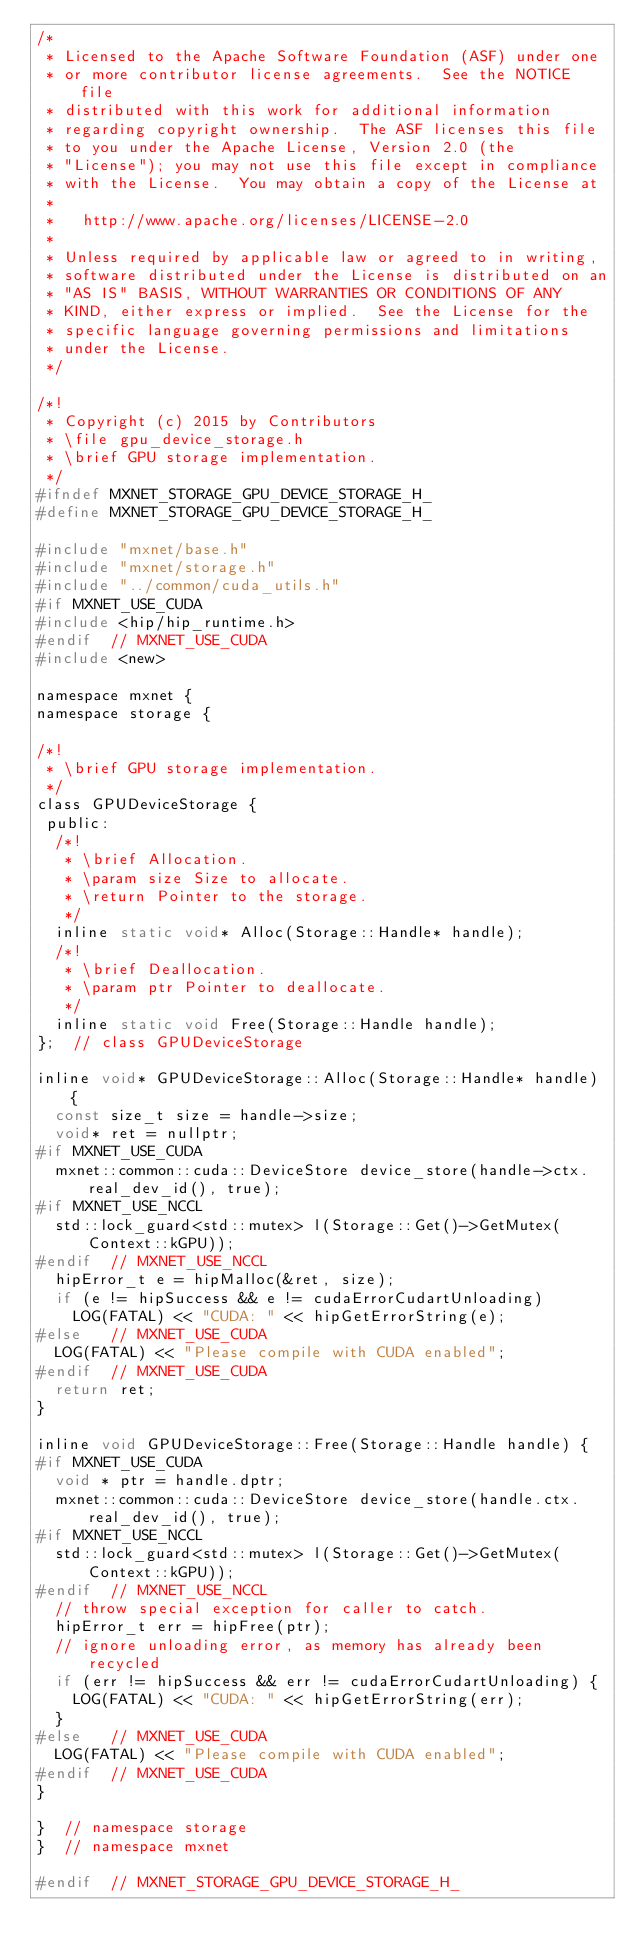Convert code to text. <code><loc_0><loc_0><loc_500><loc_500><_C_>/*
 * Licensed to the Apache Software Foundation (ASF) under one
 * or more contributor license agreements.  See the NOTICE file
 * distributed with this work for additional information
 * regarding copyright ownership.  The ASF licenses this file
 * to you under the Apache License, Version 2.0 (the
 * "License"); you may not use this file except in compliance
 * with the License.  You may obtain a copy of the License at
 *
 *   http://www.apache.org/licenses/LICENSE-2.0
 *
 * Unless required by applicable law or agreed to in writing,
 * software distributed under the License is distributed on an
 * "AS IS" BASIS, WITHOUT WARRANTIES OR CONDITIONS OF ANY
 * KIND, either express or implied.  See the License for the
 * specific language governing permissions and limitations
 * under the License.
 */

/*!
 * Copyright (c) 2015 by Contributors
 * \file gpu_device_storage.h
 * \brief GPU storage implementation.
 */
#ifndef MXNET_STORAGE_GPU_DEVICE_STORAGE_H_
#define MXNET_STORAGE_GPU_DEVICE_STORAGE_H_

#include "mxnet/base.h"
#include "mxnet/storage.h"
#include "../common/cuda_utils.h"
#if MXNET_USE_CUDA
#include <hip/hip_runtime.h>
#endif  // MXNET_USE_CUDA
#include <new>

namespace mxnet {
namespace storage {

/*!
 * \brief GPU storage implementation.
 */
class GPUDeviceStorage {
 public:
  /*!
   * \brief Allocation.
   * \param size Size to allocate.
   * \return Pointer to the storage.
   */
  inline static void* Alloc(Storage::Handle* handle);
  /*!
   * \brief Deallocation.
   * \param ptr Pointer to deallocate.
   */
  inline static void Free(Storage::Handle handle);
};  // class GPUDeviceStorage

inline void* GPUDeviceStorage::Alloc(Storage::Handle* handle) {
  const size_t size = handle->size;
  void* ret = nullptr;
#if MXNET_USE_CUDA
  mxnet::common::cuda::DeviceStore device_store(handle->ctx.real_dev_id(), true);
#if MXNET_USE_NCCL
  std::lock_guard<std::mutex> l(Storage::Get()->GetMutex(Context::kGPU));
#endif  // MXNET_USE_NCCL
  hipError_t e = hipMalloc(&ret, size);
  if (e != hipSuccess && e != cudaErrorCudartUnloading)
    LOG(FATAL) << "CUDA: " << hipGetErrorString(e);
#else   // MXNET_USE_CUDA
  LOG(FATAL) << "Please compile with CUDA enabled";
#endif  // MXNET_USE_CUDA
  return ret;
}

inline void GPUDeviceStorage::Free(Storage::Handle handle) {
#if MXNET_USE_CUDA
  void * ptr = handle.dptr;
  mxnet::common::cuda::DeviceStore device_store(handle.ctx.real_dev_id(), true);
#if MXNET_USE_NCCL
  std::lock_guard<std::mutex> l(Storage::Get()->GetMutex(Context::kGPU));
#endif  // MXNET_USE_NCCL
  // throw special exception for caller to catch.
  hipError_t err = hipFree(ptr);
  // ignore unloading error, as memory has already been recycled
  if (err != hipSuccess && err != cudaErrorCudartUnloading) {
    LOG(FATAL) << "CUDA: " << hipGetErrorString(err);
  }
#else   // MXNET_USE_CUDA
  LOG(FATAL) << "Please compile with CUDA enabled";
#endif  // MXNET_USE_CUDA
}

}  // namespace storage
}  // namespace mxnet

#endif  // MXNET_STORAGE_GPU_DEVICE_STORAGE_H_
</code> 